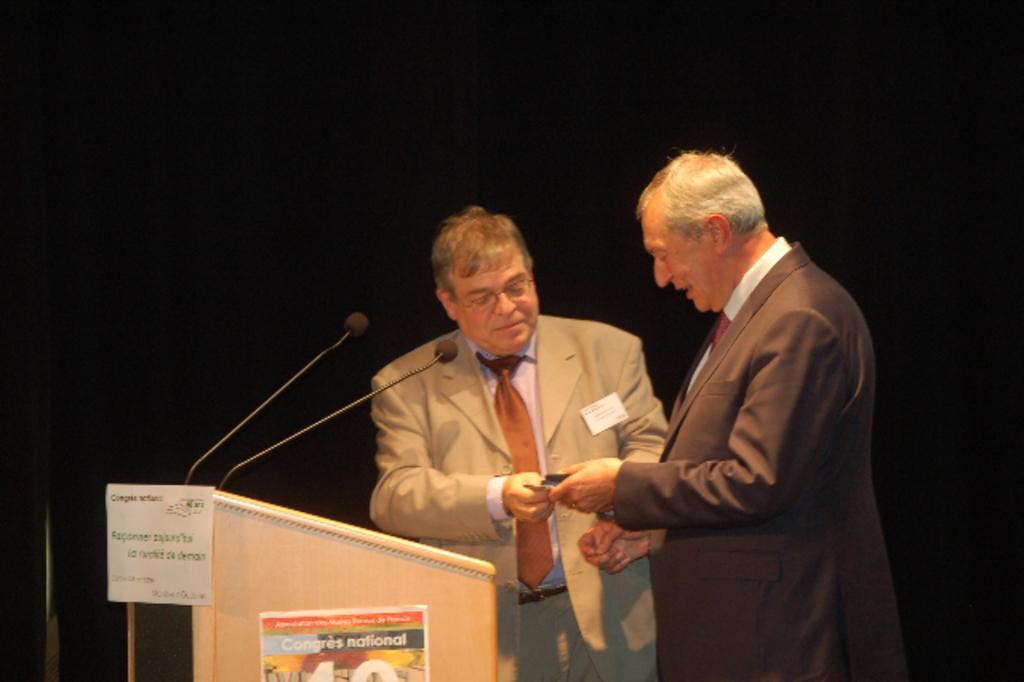Describe this image in one or two sentences. In the image we can see there are men standing near the podium and there are mics on the podium. The men are wearing formal suit and they both are holding a paper in their hand. 